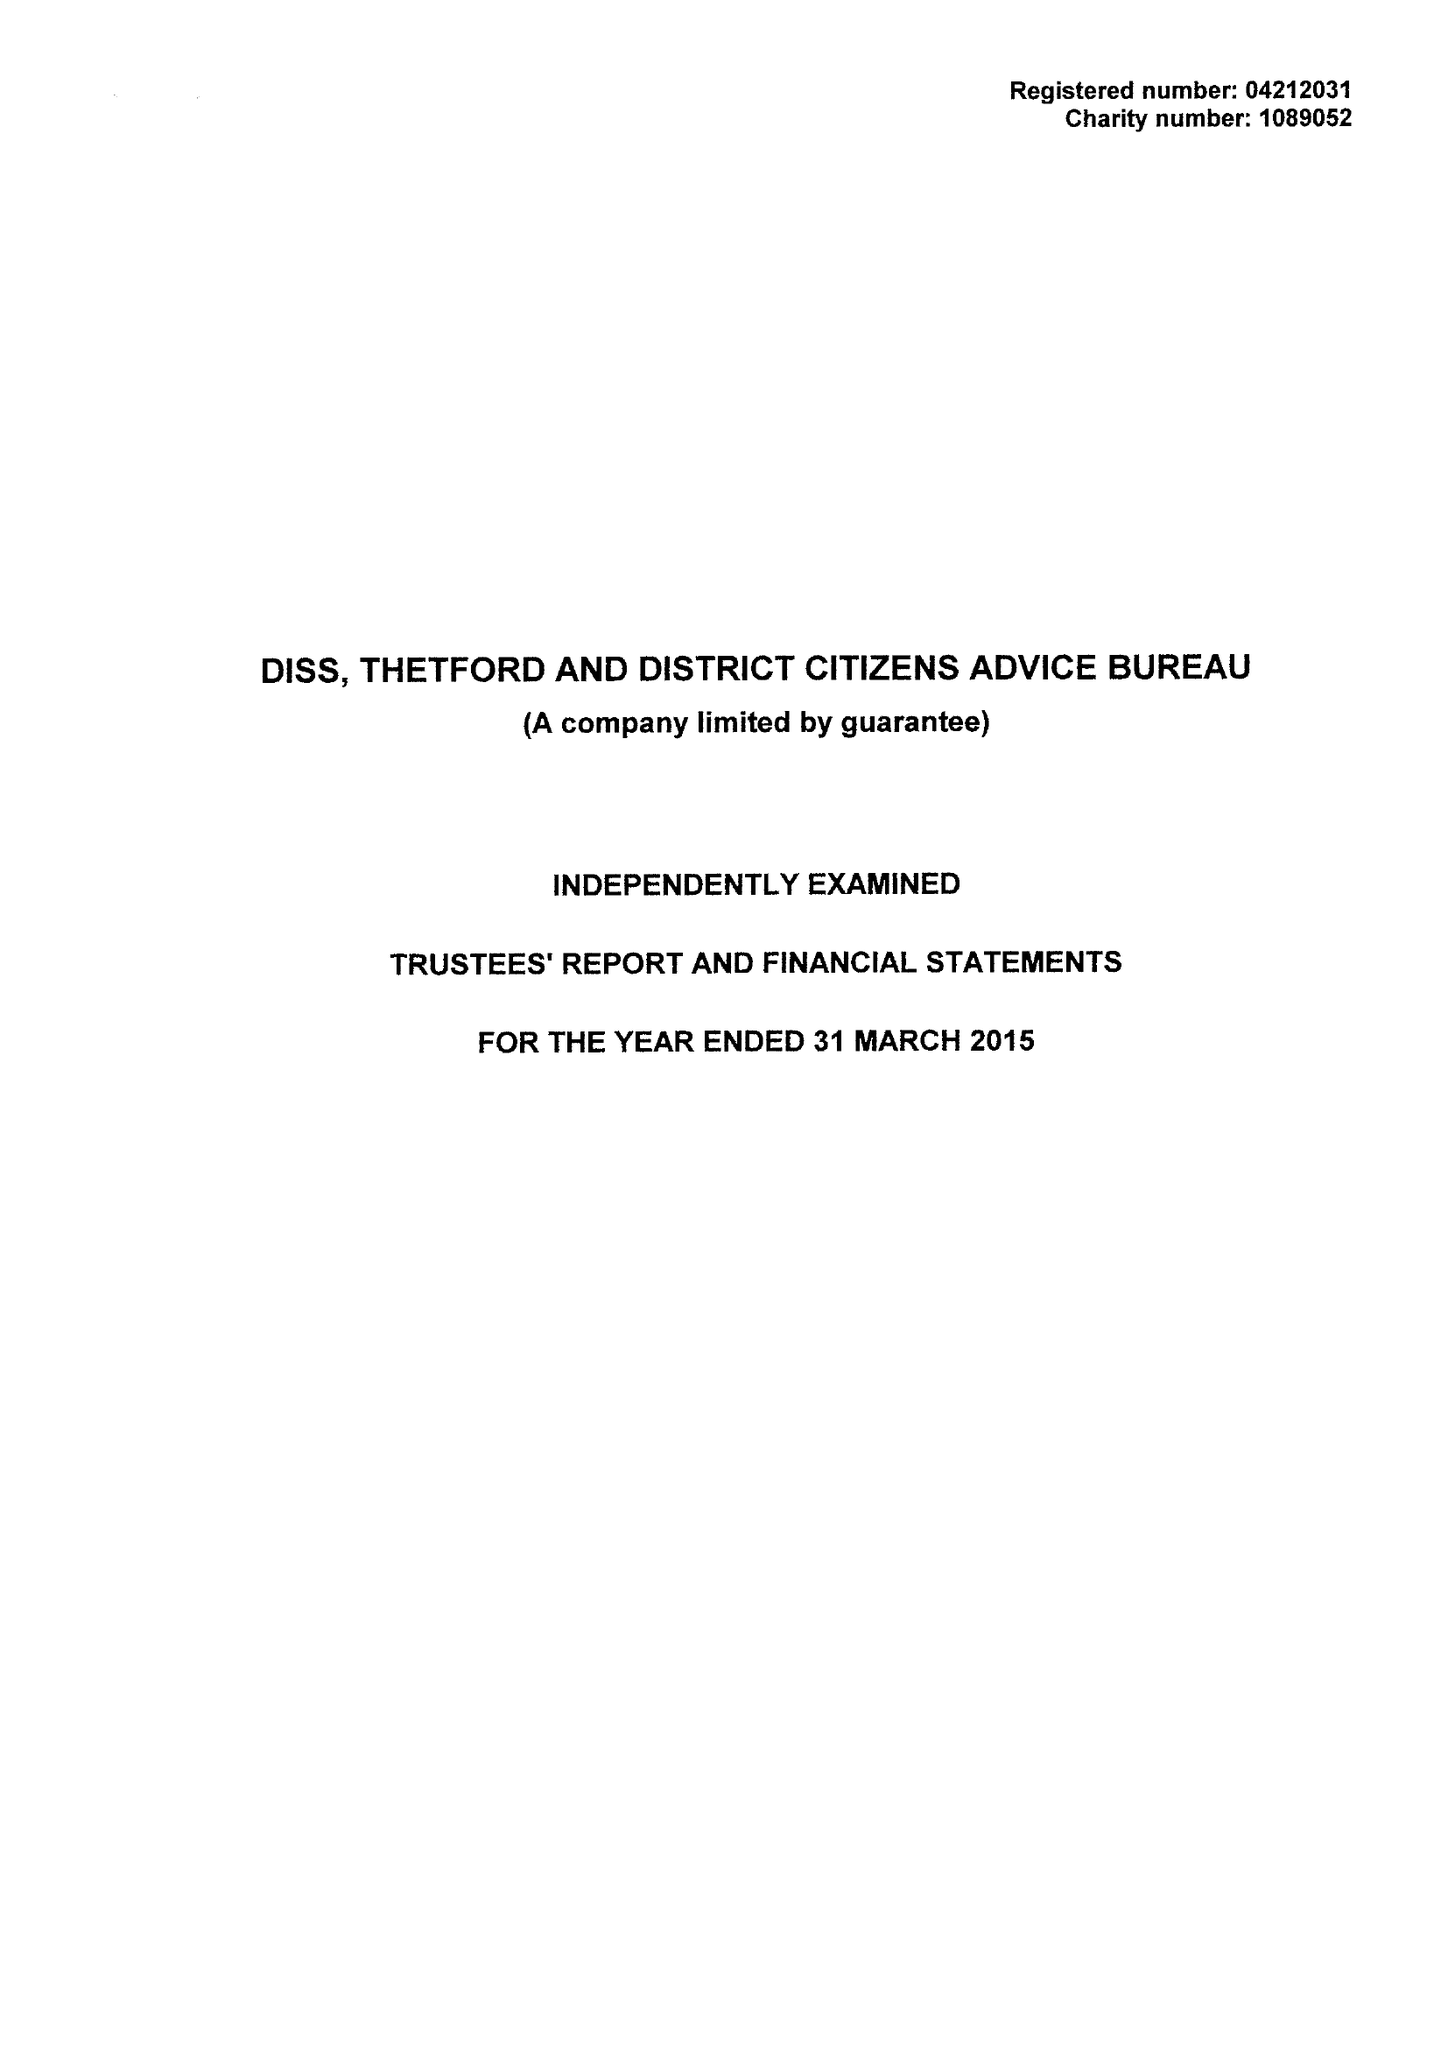What is the value for the report_date?
Answer the question using a single word or phrase. 2015-03-31 